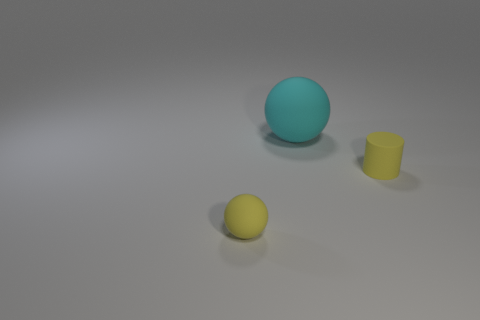Subtract all gray cylinders. Subtract all cyan spheres. How many cylinders are left? 1 Add 3 small yellow things. How many objects exist? 6 Subtract all cylinders. How many objects are left? 2 Add 1 matte objects. How many matte objects are left? 4 Add 3 large things. How many large things exist? 4 Subtract 0 purple blocks. How many objects are left? 3 Subtract all large cyan things. Subtract all rubber balls. How many objects are left? 0 